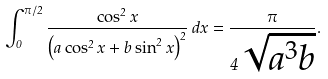Convert formula to latex. <formula><loc_0><loc_0><loc_500><loc_500>\int _ { 0 } ^ { \pi / 2 } { \frac { \cos ^ { 2 } x } { \left ( a \cos ^ { 2 } x + b \sin ^ { 2 } x \right ) ^ { 2 } } } \, d x = { \frac { \pi } { 4 { \sqrt { a ^ { 3 } b } } } } .</formula> 